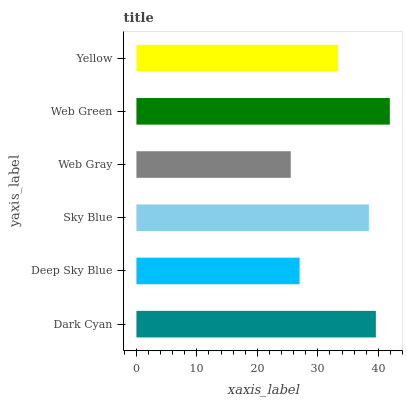Is Web Gray the minimum?
Answer yes or no. Yes. Is Web Green the maximum?
Answer yes or no. Yes. Is Deep Sky Blue the minimum?
Answer yes or no. No. Is Deep Sky Blue the maximum?
Answer yes or no. No. Is Dark Cyan greater than Deep Sky Blue?
Answer yes or no. Yes. Is Deep Sky Blue less than Dark Cyan?
Answer yes or no. Yes. Is Deep Sky Blue greater than Dark Cyan?
Answer yes or no. No. Is Dark Cyan less than Deep Sky Blue?
Answer yes or no. No. Is Sky Blue the high median?
Answer yes or no. Yes. Is Yellow the low median?
Answer yes or no. Yes. Is Dark Cyan the high median?
Answer yes or no. No. Is Dark Cyan the low median?
Answer yes or no. No. 